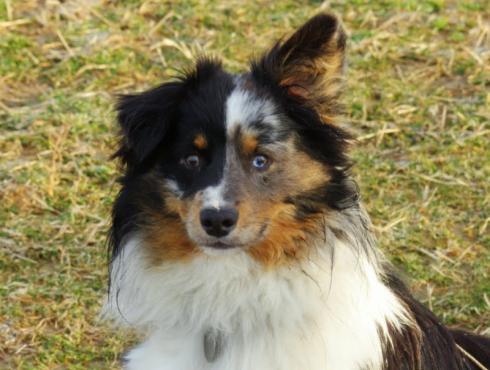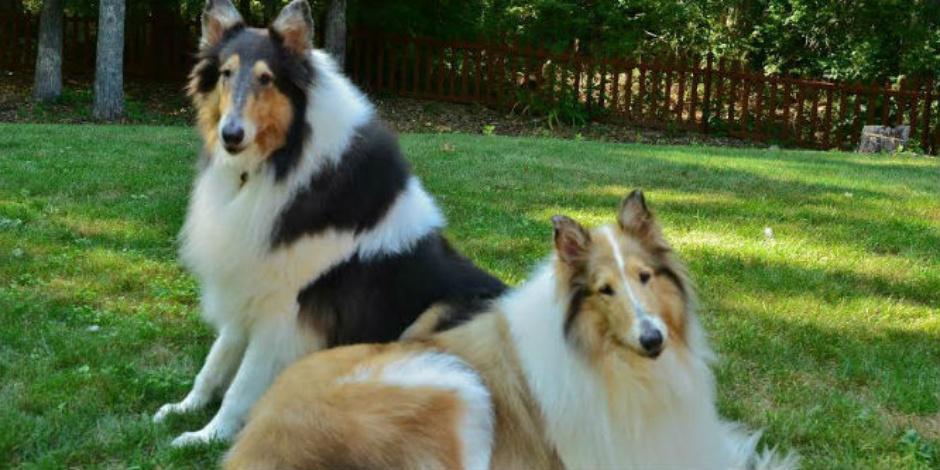The first image is the image on the left, the second image is the image on the right. For the images shown, is this caption "The right image contains exactly two dogs." true? Answer yes or no. Yes. The first image is the image on the left, the second image is the image on the right. For the images displayed, is the sentence "No single image contains more than two dogs, all images show dogs on a grass background, and at least one image includes a familiar collie breed." factually correct? Answer yes or no. Yes. 